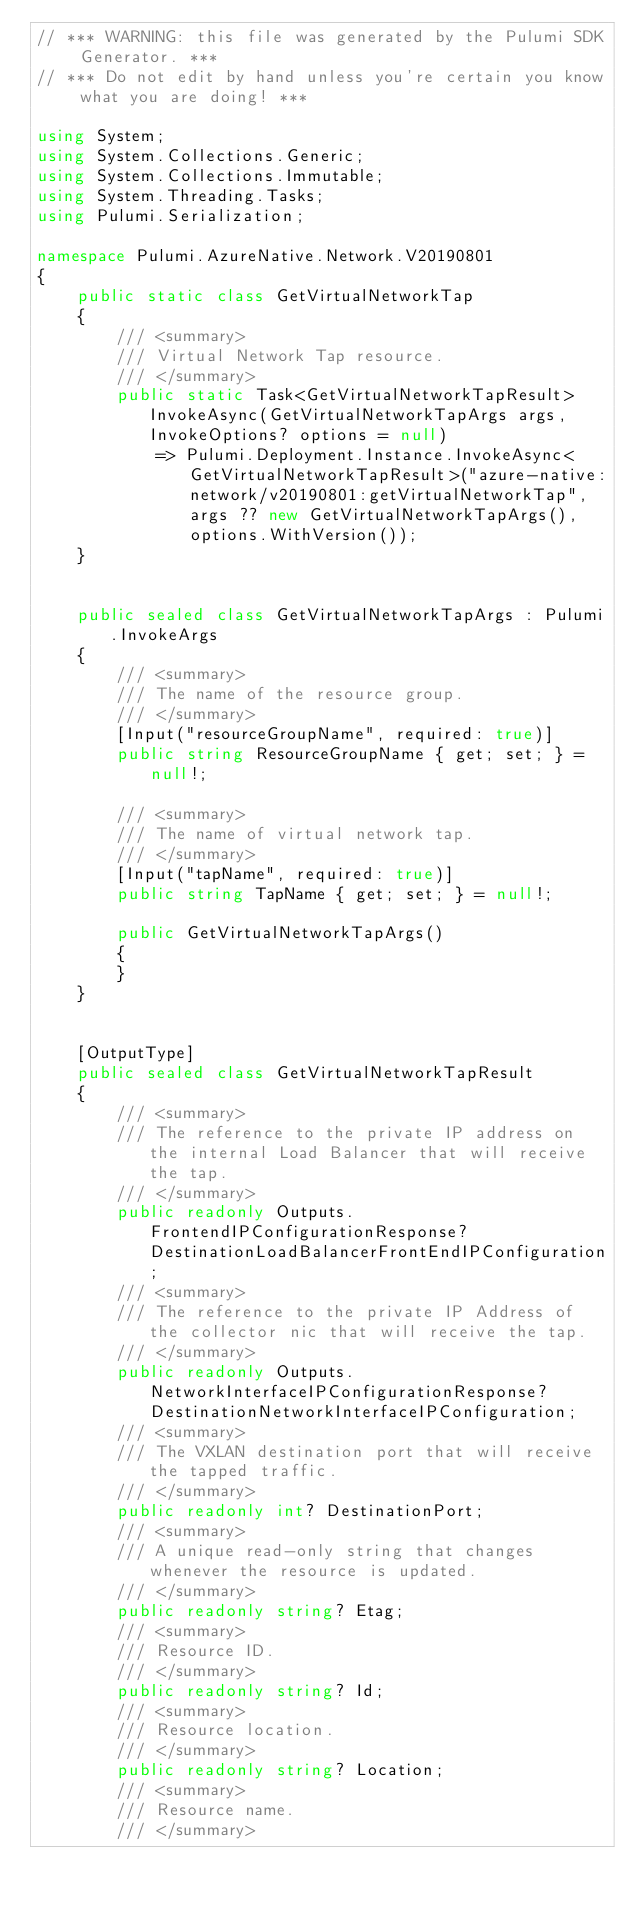<code> <loc_0><loc_0><loc_500><loc_500><_C#_>// *** WARNING: this file was generated by the Pulumi SDK Generator. ***
// *** Do not edit by hand unless you're certain you know what you are doing! ***

using System;
using System.Collections.Generic;
using System.Collections.Immutable;
using System.Threading.Tasks;
using Pulumi.Serialization;

namespace Pulumi.AzureNative.Network.V20190801
{
    public static class GetVirtualNetworkTap
    {
        /// <summary>
        /// Virtual Network Tap resource.
        /// </summary>
        public static Task<GetVirtualNetworkTapResult> InvokeAsync(GetVirtualNetworkTapArgs args, InvokeOptions? options = null)
            => Pulumi.Deployment.Instance.InvokeAsync<GetVirtualNetworkTapResult>("azure-native:network/v20190801:getVirtualNetworkTap", args ?? new GetVirtualNetworkTapArgs(), options.WithVersion());
    }


    public sealed class GetVirtualNetworkTapArgs : Pulumi.InvokeArgs
    {
        /// <summary>
        /// The name of the resource group.
        /// </summary>
        [Input("resourceGroupName", required: true)]
        public string ResourceGroupName { get; set; } = null!;

        /// <summary>
        /// The name of virtual network tap.
        /// </summary>
        [Input("tapName", required: true)]
        public string TapName { get; set; } = null!;

        public GetVirtualNetworkTapArgs()
        {
        }
    }


    [OutputType]
    public sealed class GetVirtualNetworkTapResult
    {
        /// <summary>
        /// The reference to the private IP address on the internal Load Balancer that will receive the tap.
        /// </summary>
        public readonly Outputs.FrontendIPConfigurationResponse? DestinationLoadBalancerFrontEndIPConfiguration;
        /// <summary>
        /// The reference to the private IP Address of the collector nic that will receive the tap.
        /// </summary>
        public readonly Outputs.NetworkInterfaceIPConfigurationResponse? DestinationNetworkInterfaceIPConfiguration;
        /// <summary>
        /// The VXLAN destination port that will receive the tapped traffic.
        /// </summary>
        public readonly int? DestinationPort;
        /// <summary>
        /// A unique read-only string that changes whenever the resource is updated.
        /// </summary>
        public readonly string? Etag;
        /// <summary>
        /// Resource ID.
        /// </summary>
        public readonly string? Id;
        /// <summary>
        /// Resource location.
        /// </summary>
        public readonly string? Location;
        /// <summary>
        /// Resource name.
        /// </summary></code> 